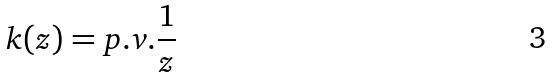Convert formula to latex. <formula><loc_0><loc_0><loc_500><loc_500>k ( z ) = p . v . \frac { 1 } { z }</formula> 